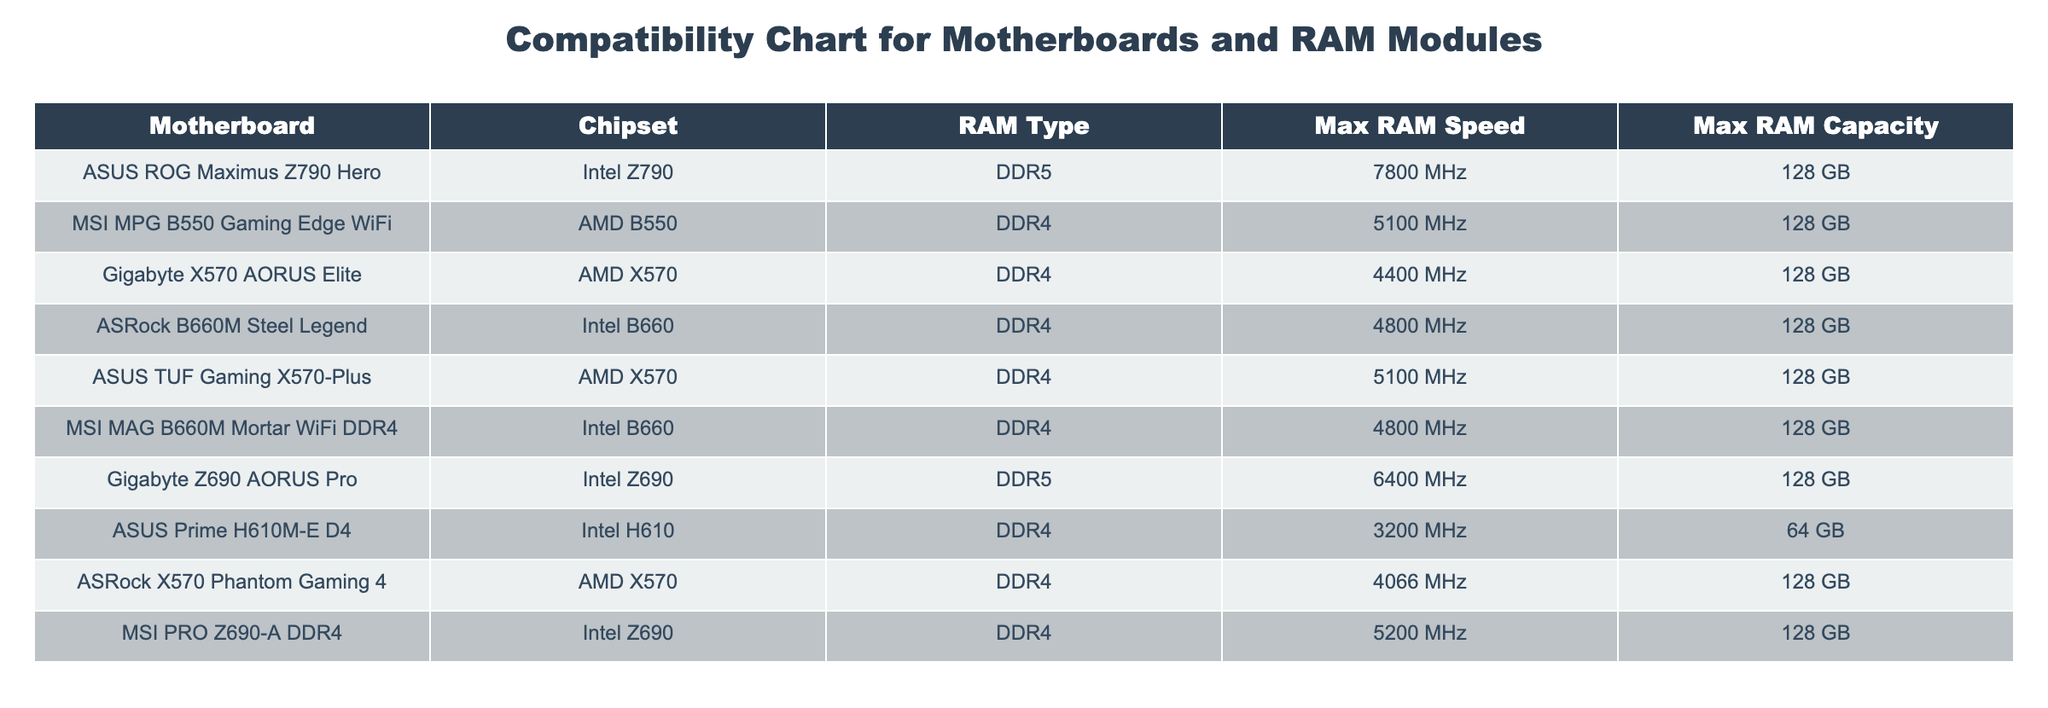What type of RAM is compatible with the ASUS ROG Maximus Z790 Hero motherboard? The table shows that the ASUS ROG Maximus Z790 Hero supports DDR5 RAM.
Answer: DDR5 Which motherboard supports a maximum RAM speed of 7800 MHz? By checking the table, the ASUS ROG Maximus Z790 Hero motherboard is listed with a maximum RAM speed of 7800 MHz.
Answer: ASUS ROG Maximus Z790 Hero Is the maximum RAM capacity for all listed motherboards the same? The table shows that all motherboards listed have a maximum RAM capacity of 128 GB, except for the ASUS Prime H610M-E D4 which has 64 GB. Therefore, not all are the same.
Answer: No Which motherboard has the highest maximum RAM speed? Upon reviewing the table, the ASUS ROG Maximus Z790 Hero has the highest maximum RAM speed listed, which is 7800 MHz.
Answer: ASUS ROG Maximus Z790 Hero What is the average maximum RAM speed for AMD motherboards in this table? The maximum RAM speeds for AMD motherboards (MSI MPG B550 Gaming Edge WiFi, Gigabyte X570 AORUS Elite, ASUS TUF Gaming X570-Plus, ASRock X570 Phantom Gaming 4) are 5100 MHz, 4400 MHz, 5100 MHz, and 4066 MHz. The total is (5100 + 4400 + 5100 + 4066) = 18666 MHz. There are four AMD motherboards, so the average is 18666/4 = 4666.5 MHz.
Answer: 4666.5 MHz Is it true that all Intel motherboards listed can support DDR5 RAM? The table indicates that only the ASUS ROG Maximus Z790 Hero and Gigabyte Z690 AORUS Pro motherboards support DDR5 RAM, so it is not true that all Intel motherboards support DDR5.
Answer: No Which motherboard has the lowest maximum RAM capacity? By examining the table, the ASUS Prime H610M-E D4 has the lowest maximum RAM capacity at 64 GB.
Answer: ASUS Prime H610M-E D4 How many motherboards listed support DDR4 RAM? In the table, six motherboards (MSI MPG B550 Gaming Edge WiFi, Gigabyte X570 AORUS Elite, ASRock B660M Steel Legend, ASUS TUF Gaming X570-Plus, MSI MAG B660M Mortar WiFi DDR4, and MSI PRO Z690-A DDR4) support DDR4 RAM. Therefore, there are six.
Answer: 6 